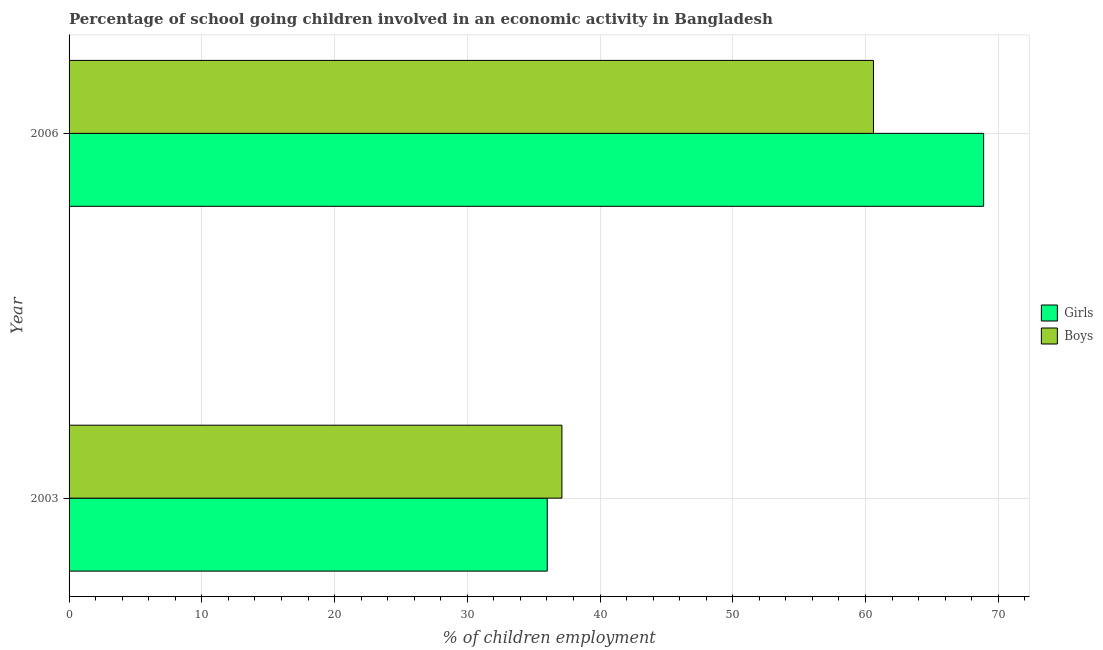How many different coloured bars are there?
Your response must be concise. 2. Are the number of bars per tick equal to the number of legend labels?
Offer a terse response. Yes. How many bars are there on the 1st tick from the top?
Your answer should be compact. 2. How many bars are there on the 1st tick from the bottom?
Ensure brevity in your answer.  2. What is the label of the 2nd group of bars from the top?
Give a very brief answer. 2003. What is the percentage of school going boys in 2006?
Ensure brevity in your answer.  60.6. Across all years, what is the maximum percentage of school going girls?
Provide a short and direct response. 68.9. Across all years, what is the minimum percentage of school going girls?
Offer a very short reply. 36.02. In which year was the percentage of school going girls maximum?
Give a very brief answer. 2006. In which year was the percentage of school going girls minimum?
Ensure brevity in your answer.  2003. What is the total percentage of school going girls in the graph?
Provide a succinct answer. 104.92. What is the difference between the percentage of school going girls in 2003 and that in 2006?
Your answer should be compact. -32.88. What is the difference between the percentage of school going boys in 2003 and the percentage of school going girls in 2006?
Give a very brief answer. -31.77. What is the average percentage of school going girls per year?
Offer a very short reply. 52.46. In the year 2006, what is the difference between the percentage of school going boys and percentage of school going girls?
Provide a succinct answer. -8.3. In how many years, is the percentage of school going boys greater than 42 %?
Ensure brevity in your answer.  1. What is the ratio of the percentage of school going boys in 2003 to that in 2006?
Your answer should be compact. 0.61. Is the percentage of school going boys in 2003 less than that in 2006?
Offer a terse response. Yes. What does the 2nd bar from the top in 2003 represents?
Keep it short and to the point. Girls. What does the 1st bar from the bottom in 2006 represents?
Ensure brevity in your answer.  Girls. How many years are there in the graph?
Give a very brief answer. 2. Are the values on the major ticks of X-axis written in scientific E-notation?
Give a very brief answer. No. Where does the legend appear in the graph?
Offer a terse response. Center right. How many legend labels are there?
Provide a succinct answer. 2. How are the legend labels stacked?
Your answer should be very brief. Vertical. What is the title of the graph?
Give a very brief answer. Percentage of school going children involved in an economic activity in Bangladesh. Does "Revenue" appear as one of the legend labels in the graph?
Your answer should be very brief. No. What is the label or title of the X-axis?
Keep it short and to the point. % of children employment. What is the label or title of the Y-axis?
Offer a terse response. Year. What is the % of children employment of Girls in 2003?
Provide a short and direct response. 36.02. What is the % of children employment in Boys in 2003?
Your answer should be compact. 37.13. What is the % of children employment in Girls in 2006?
Give a very brief answer. 68.9. What is the % of children employment of Boys in 2006?
Keep it short and to the point. 60.6. Across all years, what is the maximum % of children employment in Girls?
Ensure brevity in your answer.  68.9. Across all years, what is the maximum % of children employment in Boys?
Offer a terse response. 60.6. Across all years, what is the minimum % of children employment of Girls?
Offer a very short reply. 36.02. Across all years, what is the minimum % of children employment of Boys?
Your answer should be very brief. 37.13. What is the total % of children employment of Girls in the graph?
Your answer should be compact. 104.92. What is the total % of children employment in Boys in the graph?
Your response must be concise. 97.73. What is the difference between the % of children employment in Girls in 2003 and that in 2006?
Make the answer very short. -32.88. What is the difference between the % of children employment of Boys in 2003 and that in 2006?
Provide a short and direct response. -23.47. What is the difference between the % of children employment of Girls in 2003 and the % of children employment of Boys in 2006?
Give a very brief answer. -24.58. What is the average % of children employment in Girls per year?
Your answer should be very brief. 52.46. What is the average % of children employment of Boys per year?
Keep it short and to the point. 48.86. In the year 2003, what is the difference between the % of children employment in Girls and % of children employment in Boys?
Give a very brief answer. -1.11. In the year 2006, what is the difference between the % of children employment in Girls and % of children employment in Boys?
Make the answer very short. 8.3. What is the ratio of the % of children employment of Girls in 2003 to that in 2006?
Your answer should be compact. 0.52. What is the ratio of the % of children employment of Boys in 2003 to that in 2006?
Provide a succinct answer. 0.61. What is the difference between the highest and the second highest % of children employment of Girls?
Ensure brevity in your answer.  32.88. What is the difference between the highest and the second highest % of children employment of Boys?
Offer a terse response. 23.47. What is the difference between the highest and the lowest % of children employment of Girls?
Your answer should be compact. 32.88. What is the difference between the highest and the lowest % of children employment in Boys?
Offer a very short reply. 23.47. 